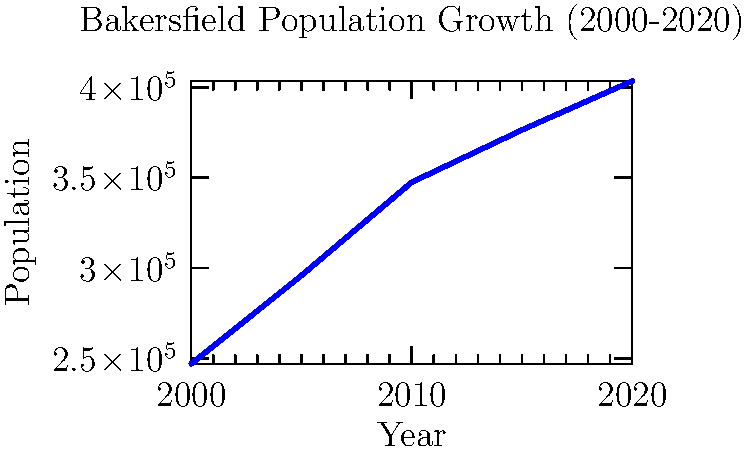Based on the line graph showing Bakersfield's population growth from 2000 to 2020, what was the approximate increase in population between 2010 and 2020? To find the population increase between 2010 and 2020:

1. Locate the population value for 2010 on the graph: approximately 347,483
2. Locate the population value for 2020 on the graph: approximately 403,455
3. Calculate the difference:
   $403,455 - 347,483 = 55,972$

The population increase between 2010 and 2020 was approximately 56,000 people.

Note: As a long-time resident of Bakersfield, you may have noticed this significant growth in your daily life, such as increased traffic or new housing developments.
Answer: Approximately 56,000 